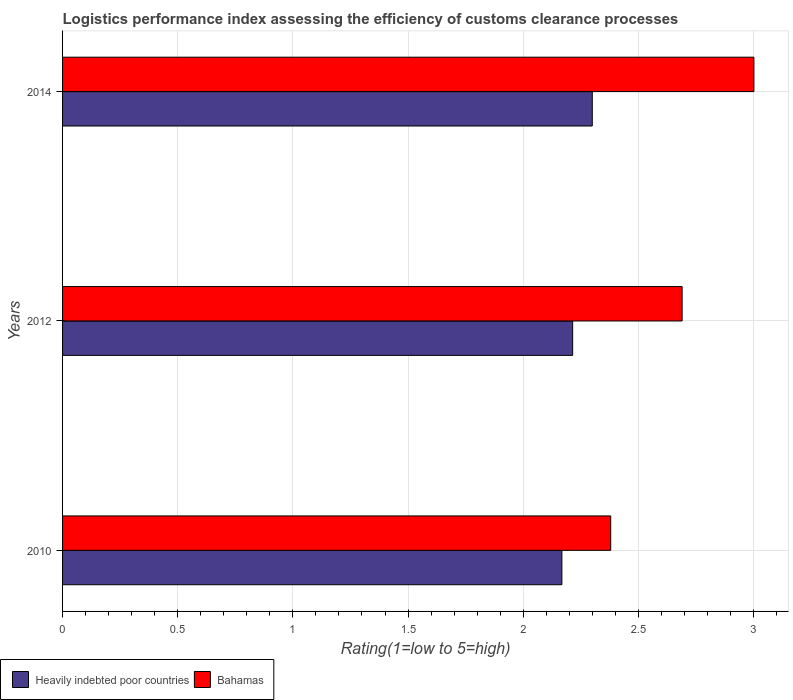How many groups of bars are there?
Provide a succinct answer. 3. How many bars are there on the 2nd tick from the top?
Keep it short and to the point. 2. How many bars are there on the 1st tick from the bottom?
Provide a succinct answer. 2. In how many cases, is the number of bars for a given year not equal to the number of legend labels?
Offer a terse response. 0. What is the Logistic performance index in Heavily indebted poor countries in 2014?
Give a very brief answer. 2.3. Across all years, what is the maximum Logistic performance index in Bahamas?
Provide a short and direct response. 3. Across all years, what is the minimum Logistic performance index in Bahamas?
Make the answer very short. 2.38. In which year was the Logistic performance index in Heavily indebted poor countries maximum?
Provide a short and direct response. 2014. In which year was the Logistic performance index in Bahamas minimum?
Offer a very short reply. 2010. What is the total Logistic performance index in Bahamas in the graph?
Offer a terse response. 8.07. What is the difference between the Logistic performance index in Heavily indebted poor countries in 2012 and that in 2014?
Provide a succinct answer. -0.09. What is the difference between the Logistic performance index in Heavily indebted poor countries in 2014 and the Logistic performance index in Bahamas in 2012?
Your answer should be compact. -0.39. What is the average Logistic performance index in Bahamas per year?
Ensure brevity in your answer.  2.69. In the year 2010, what is the difference between the Logistic performance index in Heavily indebted poor countries and Logistic performance index in Bahamas?
Ensure brevity in your answer.  -0.21. In how many years, is the Logistic performance index in Heavily indebted poor countries greater than 1.8 ?
Give a very brief answer. 3. What is the ratio of the Logistic performance index in Heavily indebted poor countries in 2012 to that in 2014?
Your response must be concise. 0.96. Is the difference between the Logistic performance index in Heavily indebted poor countries in 2010 and 2012 greater than the difference between the Logistic performance index in Bahamas in 2010 and 2012?
Your answer should be very brief. Yes. What is the difference between the highest and the second highest Logistic performance index in Bahamas?
Your response must be concise. 0.31. What is the difference between the highest and the lowest Logistic performance index in Heavily indebted poor countries?
Make the answer very short. 0.13. Is the sum of the Logistic performance index in Heavily indebted poor countries in 2012 and 2014 greater than the maximum Logistic performance index in Bahamas across all years?
Provide a succinct answer. Yes. What does the 2nd bar from the top in 2012 represents?
Give a very brief answer. Heavily indebted poor countries. What does the 1st bar from the bottom in 2012 represents?
Keep it short and to the point. Heavily indebted poor countries. Are all the bars in the graph horizontal?
Make the answer very short. Yes. What is the difference between two consecutive major ticks on the X-axis?
Your answer should be compact. 0.5. Are the values on the major ticks of X-axis written in scientific E-notation?
Keep it short and to the point. No. Does the graph contain any zero values?
Provide a succinct answer. No. Does the graph contain grids?
Your response must be concise. Yes. What is the title of the graph?
Your answer should be compact. Logistics performance index assessing the efficiency of customs clearance processes. What is the label or title of the X-axis?
Offer a very short reply. Rating(1=low to 5=high). What is the Rating(1=low to 5=high) in Heavily indebted poor countries in 2010?
Make the answer very short. 2.17. What is the Rating(1=low to 5=high) of Bahamas in 2010?
Ensure brevity in your answer.  2.38. What is the Rating(1=low to 5=high) of Heavily indebted poor countries in 2012?
Your answer should be compact. 2.21. What is the Rating(1=low to 5=high) in Bahamas in 2012?
Your answer should be very brief. 2.69. What is the Rating(1=low to 5=high) of Heavily indebted poor countries in 2014?
Provide a short and direct response. 2.3. What is the Rating(1=low to 5=high) in Bahamas in 2014?
Your response must be concise. 3. Across all years, what is the maximum Rating(1=low to 5=high) in Heavily indebted poor countries?
Your answer should be compact. 2.3. Across all years, what is the maximum Rating(1=low to 5=high) of Bahamas?
Give a very brief answer. 3. Across all years, what is the minimum Rating(1=low to 5=high) of Heavily indebted poor countries?
Make the answer very short. 2.17. Across all years, what is the minimum Rating(1=low to 5=high) of Bahamas?
Make the answer very short. 2.38. What is the total Rating(1=low to 5=high) in Heavily indebted poor countries in the graph?
Provide a succinct answer. 6.68. What is the total Rating(1=low to 5=high) in Bahamas in the graph?
Make the answer very short. 8.07. What is the difference between the Rating(1=low to 5=high) in Heavily indebted poor countries in 2010 and that in 2012?
Give a very brief answer. -0.05. What is the difference between the Rating(1=low to 5=high) in Bahamas in 2010 and that in 2012?
Provide a short and direct response. -0.31. What is the difference between the Rating(1=low to 5=high) of Heavily indebted poor countries in 2010 and that in 2014?
Provide a short and direct response. -0.13. What is the difference between the Rating(1=low to 5=high) of Bahamas in 2010 and that in 2014?
Give a very brief answer. -0.62. What is the difference between the Rating(1=low to 5=high) in Heavily indebted poor countries in 2012 and that in 2014?
Offer a very short reply. -0.09. What is the difference between the Rating(1=low to 5=high) of Bahamas in 2012 and that in 2014?
Provide a short and direct response. -0.31. What is the difference between the Rating(1=low to 5=high) of Heavily indebted poor countries in 2010 and the Rating(1=low to 5=high) of Bahamas in 2012?
Make the answer very short. -0.52. What is the difference between the Rating(1=low to 5=high) in Heavily indebted poor countries in 2010 and the Rating(1=low to 5=high) in Bahamas in 2014?
Give a very brief answer. -0.83. What is the difference between the Rating(1=low to 5=high) of Heavily indebted poor countries in 2012 and the Rating(1=low to 5=high) of Bahamas in 2014?
Your answer should be compact. -0.79. What is the average Rating(1=low to 5=high) of Heavily indebted poor countries per year?
Make the answer very short. 2.23. What is the average Rating(1=low to 5=high) of Bahamas per year?
Offer a terse response. 2.69. In the year 2010, what is the difference between the Rating(1=low to 5=high) in Heavily indebted poor countries and Rating(1=low to 5=high) in Bahamas?
Your answer should be compact. -0.21. In the year 2012, what is the difference between the Rating(1=low to 5=high) in Heavily indebted poor countries and Rating(1=low to 5=high) in Bahamas?
Keep it short and to the point. -0.48. In the year 2014, what is the difference between the Rating(1=low to 5=high) in Heavily indebted poor countries and Rating(1=low to 5=high) in Bahamas?
Provide a short and direct response. -0.7. What is the ratio of the Rating(1=low to 5=high) in Heavily indebted poor countries in 2010 to that in 2012?
Offer a very short reply. 0.98. What is the ratio of the Rating(1=low to 5=high) of Bahamas in 2010 to that in 2012?
Offer a very short reply. 0.88. What is the ratio of the Rating(1=low to 5=high) in Heavily indebted poor countries in 2010 to that in 2014?
Provide a succinct answer. 0.94. What is the ratio of the Rating(1=low to 5=high) in Bahamas in 2010 to that in 2014?
Provide a succinct answer. 0.79. What is the ratio of the Rating(1=low to 5=high) in Heavily indebted poor countries in 2012 to that in 2014?
Provide a short and direct response. 0.96. What is the ratio of the Rating(1=low to 5=high) in Bahamas in 2012 to that in 2014?
Your answer should be very brief. 0.9. What is the difference between the highest and the second highest Rating(1=low to 5=high) of Heavily indebted poor countries?
Offer a very short reply. 0.09. What is the difference between the highest and the second highest Rating(1=low to 5=high) in Bahamas?
Keep it short and to the point. 0.31. What is the difference between the highest and the lowest Rating(1=low to 5=high) of Heavily indebted poor countries?
Ensure brevity in your answer.  0.13. What is the difference between the highest and the lowest Rating(1=low to 5=high) of Bahamas?
Keep it short and to the point. 0.62. 